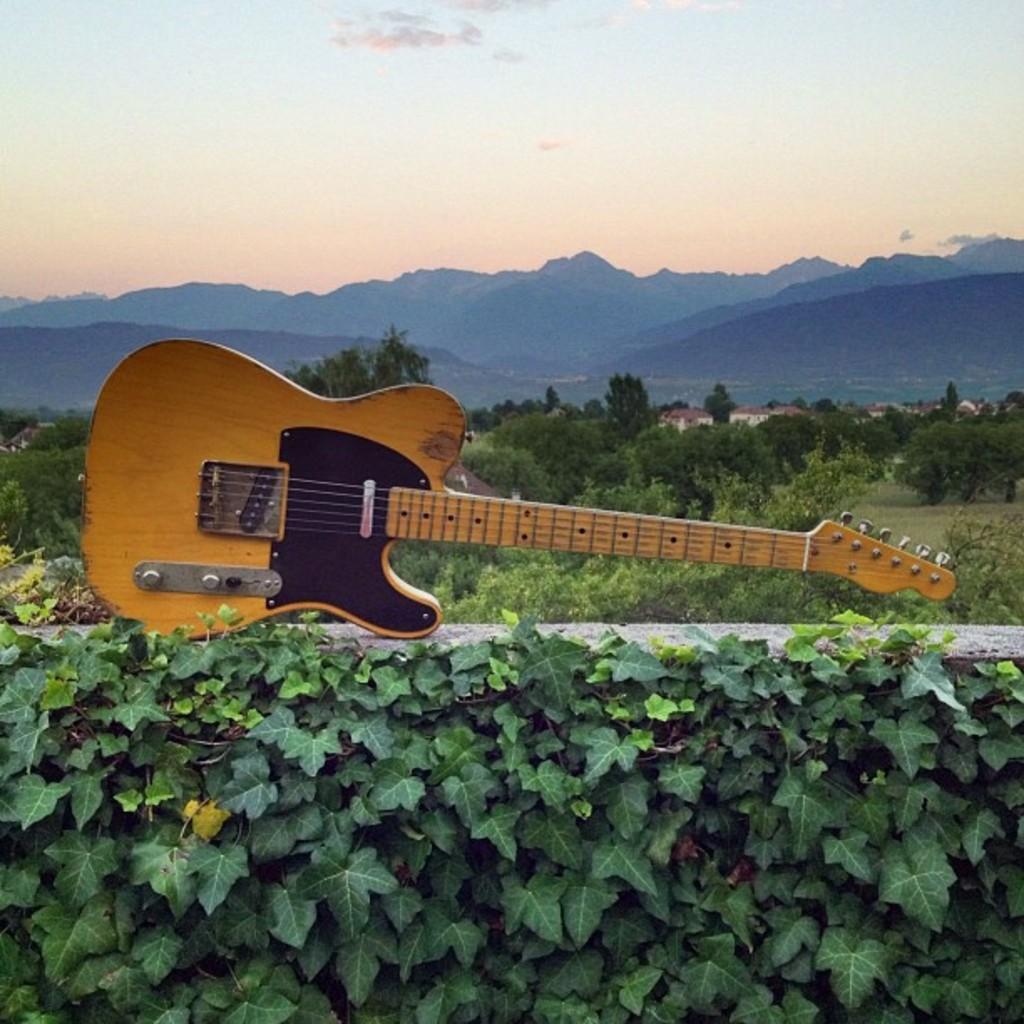Can you describe this image briefly? In this image I can see a guitar. In the background I can see number of trees, mountains and sky. 